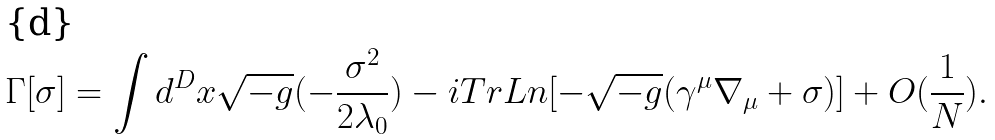<formula> <loc_0><loc_0><loc_500><loc_500>\Gamma [ \sigma ] = \int d ^ { D } x \sqrt { - g } ( - \frac { \sigma ^ { 2 } } { 2 \lambda _ { 0 } } ) - i T r L n [ - \sqrt { - g } ( \gamma ^ { \mu } \nabla _ { \mu } + \sigma ) ] + O ( \frac { 1 } { N } ) .</formula> 